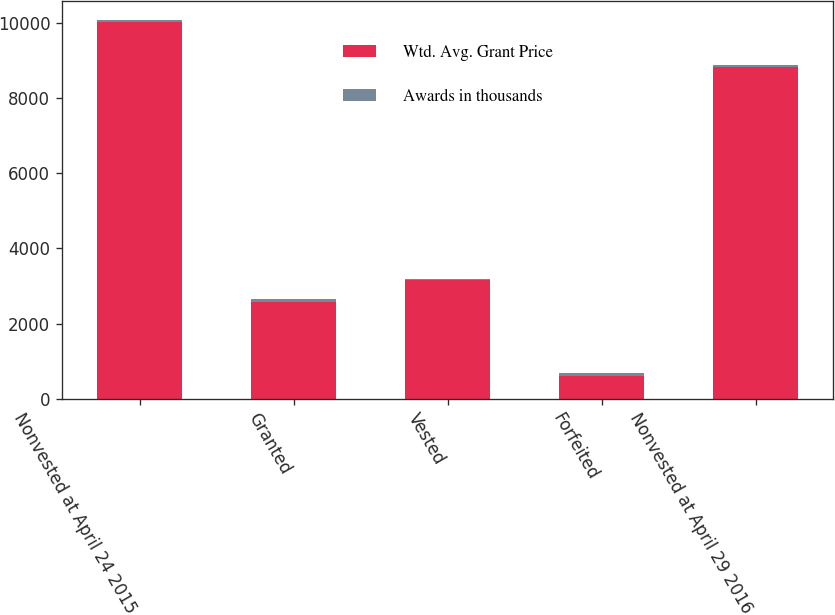<chart> <loc_0><loc_0><loc_500><loc_500><stacked_bar_chart><ecel><fcel>Nonvested at April 24 2015<fcel>Granted<fcel>Vested<fcel>Forfeited<fcel>Nonvested at April 29 2016<nl><fcel>Wtd. Avg. Grant Price<fcel>10022<fcel>2565<fcel>3148<fcel>619<fcel>8820<nl><fcel>Awards in thousands<fcel>53.88<fcel>77.68<fcel>42.96<fcel>59.16<fcel>64.33<nl></chart> 